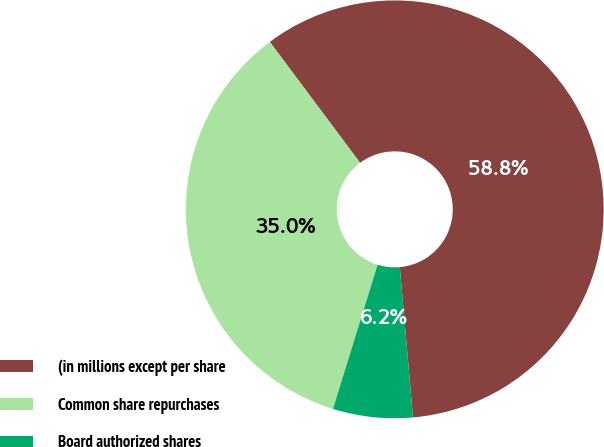Convert chart to OTSL. <chart><loc_0><loc_0><loc_500><loc_500><pie_chart><fcel>(in millions except per share<fcel>Common share repurchases<fcel>Board authorized shares<nl><fcel>58.81%<fcel>35.02%<fcel>6.17%<nl></chart> 